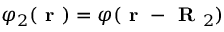Convert formula to latex. <formula><loc_0><loc_0><loc_500><loc_500>\varphi _ { 2 } ( r ) = \varphi ( r - R _ { 2 } )</formula> 